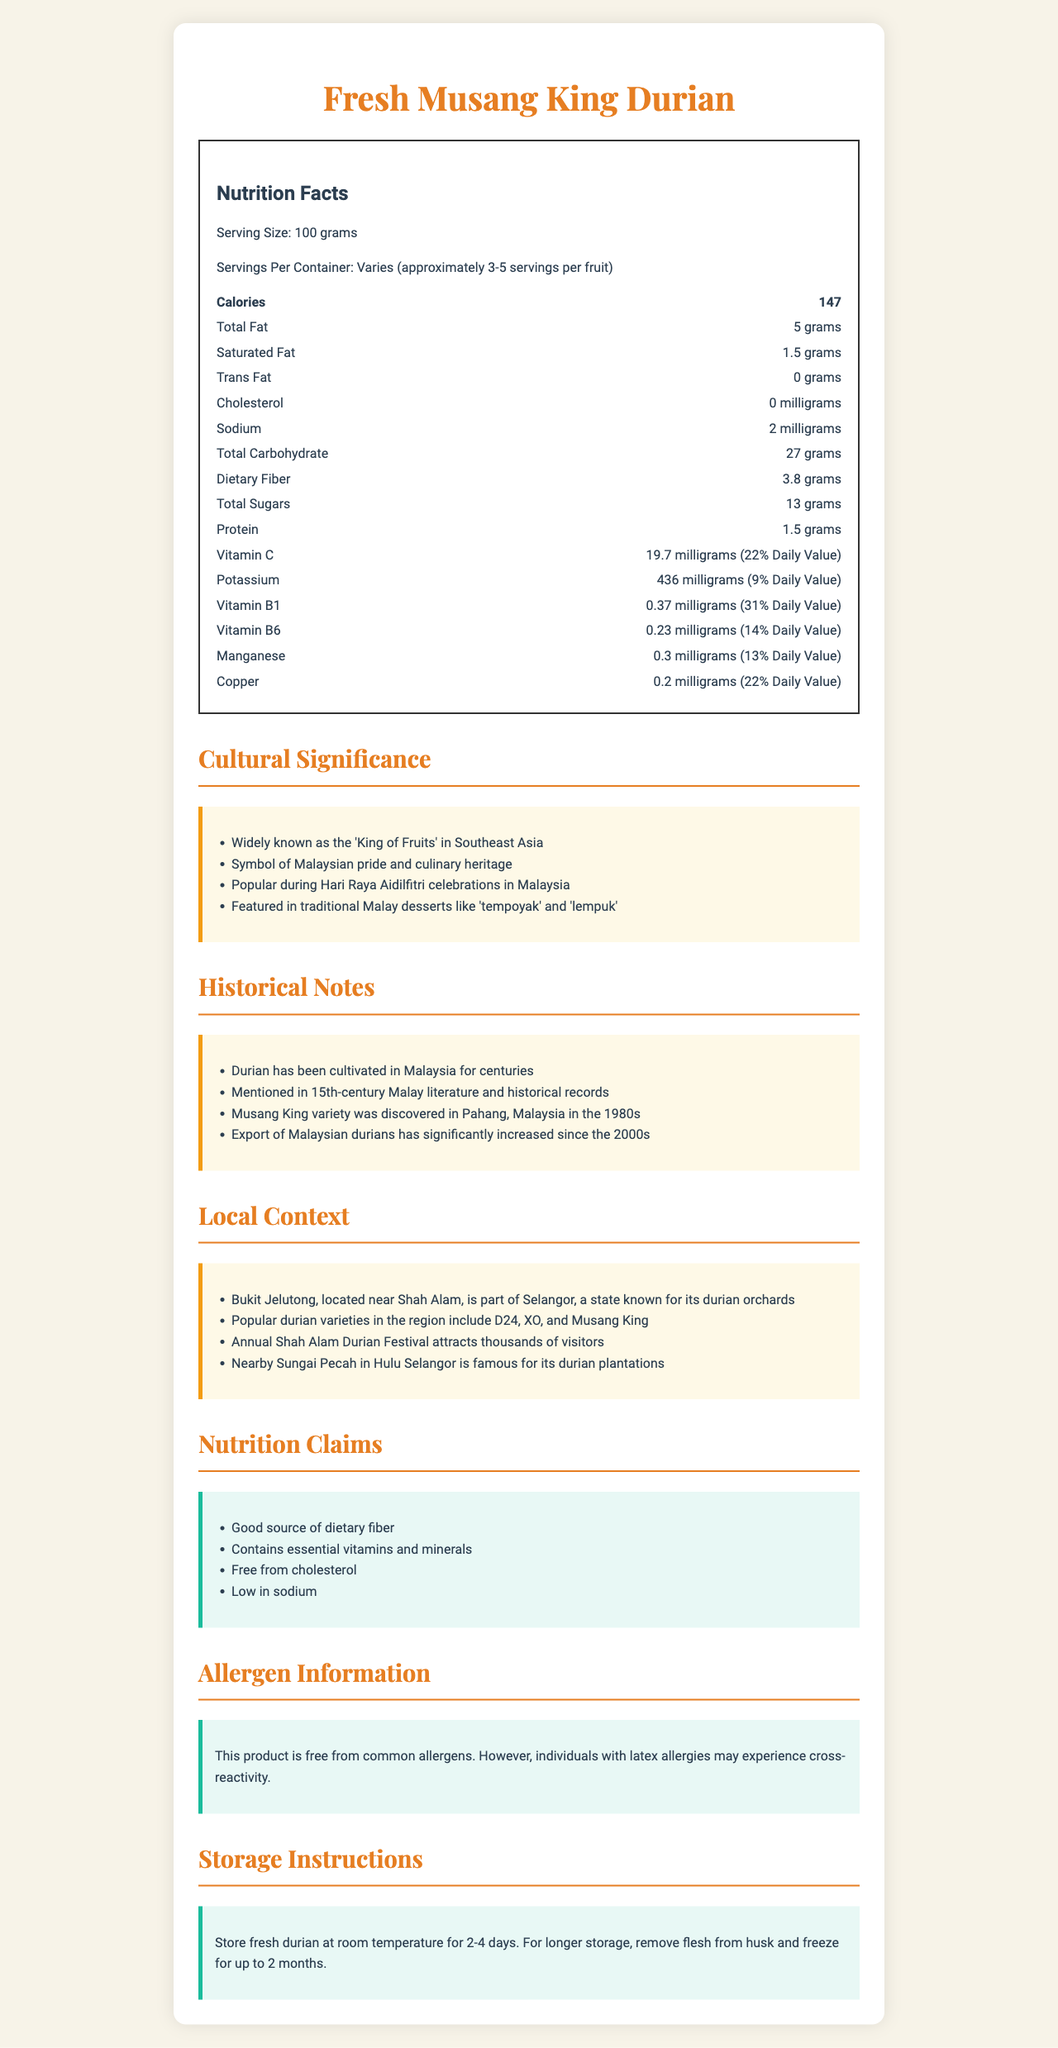what is the serving size of Fresh Musang King Durian? The serving size is clearly mentioned under the "Nutrition Facts" section of the document.
Answer: 100 grams how many calories are in a 100-gram serving of Fresh Musang King Durian? The document states that a 100-gram serving contains 147 calories.
Answer: 147 calories how much dietary fiber does a serving of Fresh Musang King Durian contain? The document lists dietary fiber as 3.8 grams per serving.
Answer: 3.8 grams what percentage of the Daily Value of vitamin C does a serving of Fresh Musang King Durian provide? The document notes that a serving provides 19.7 milligrams of vitamin C, which is 22% of the Daily Value.
Answer: 22% is there any trans fat present in Fresh Musang King Durian? The document indicates 0 grams of trans fat per serving.
Answer: No which vitamin is present in the highest percentage of the Daily Value in Fresh Musang King Durian? A. Vitamin C B. Vitamin B1 C. Vitamin B6 D. Copper Vitamin B1 is listed at 31% of the Daily Value, which is the highest among the listed vitamins and minerals.
Answer: B how much sodium is in a serving of Fresh Musang King Durian? A. 0 milligrams B. 2 milligrams C. 5 milligrams D. 10 milligrams The document states that there are 2 milligrams of sodium per serving.
Answer: B is Fresh Musang King Durian free from cholesterol? The document indicates 0 milligrams of cholesterol per serving.
Answer: Yes describe the cultural significance of durian in Malaysia. The document provides multiple points highlighting the cultural significance of durian, including its status as the 'King of Fruits,' symbolism in Malaysia, and its presence in traditional desserts and celebrations.
Answer: Known as the 'King of Fruits,' symbol of Malaysian pride, popular at Hari Raya Aidilfitri, featured in traditional desserts like 'tempoyak' and 'lempuk'. can the storage instructions for Fresh Musang King Durian be found in the document? The document includes storage instructions, stating that fresh durian should be stored at room temperature for 2-4 days, and the flesh can be frozen for up to 2 months.
Answer: Yes how has the export of Malaysian durians changed since the 2000s? The historical notes section mentions that the export of Malaysian durians has significantly increased since the 2000s.
Answer: Increased significantly where is Bukit Jelutong located and why is it relevant to Fresh Musang King Durian? The document notes that Bukit Jelutong is near Shah Alam in Selangor, a state known for its durian orchards.
Answer: Near Shah Alam, part of Selangor, known for durian orchards what are the potential allergens mentioned for Fresh Musang King Durian? The document notes that while the product is free from common allergens, individuals with latex allergies might experience cross-reactivity.
Answer: Latex cross-reactivity which of the following local events celebrates durians near Bukit Jelutong? A. Annual Shah Alam Durian Festival B. Kuala Lumpur Food Festival C. Penang Food Extravaganza The document mentions that the Annual Shah Alam Durian Festival attracts thousands of visitors.
Answer: A what is a unique variety of durian mentioned in the document that was discovered in Pahang, Malaysia in the 1980s? The historical notes mention that the Musang King variety was discovered in Pahang in the 1980s.
Answer: Musang King summarize the main idea of the document. The document is a detailed description of Fresh Musang King Durian, covering its nutritional facts, significance in Malaysian culture, historical notes, local context in Bukit Jelutong, various nutrition claims, potential allergen information, and storage guidelines.
Answer: The document provides a comprehensive overview of the nutritional profile, cultural significance, historical background, and local context of Fresh Musang King Durian, along with nutritional claims, allergen information, and storage instructions. what is the main export destination for Fresh Musang King Durian? The document does not provide information about the specific export destinations for Fresh Musang King Durian.
Answer: Cannot be determined 